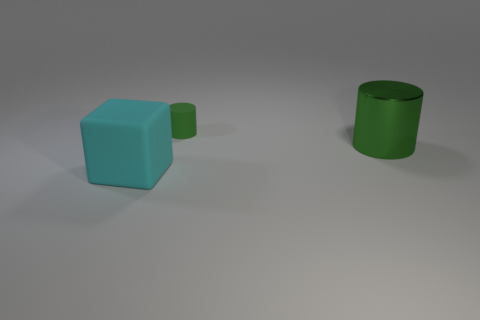Is there a green rubber cylinder that is behind the large object that is behind the big cyan matte thing that is on the left side of the small green cylinder? yes 